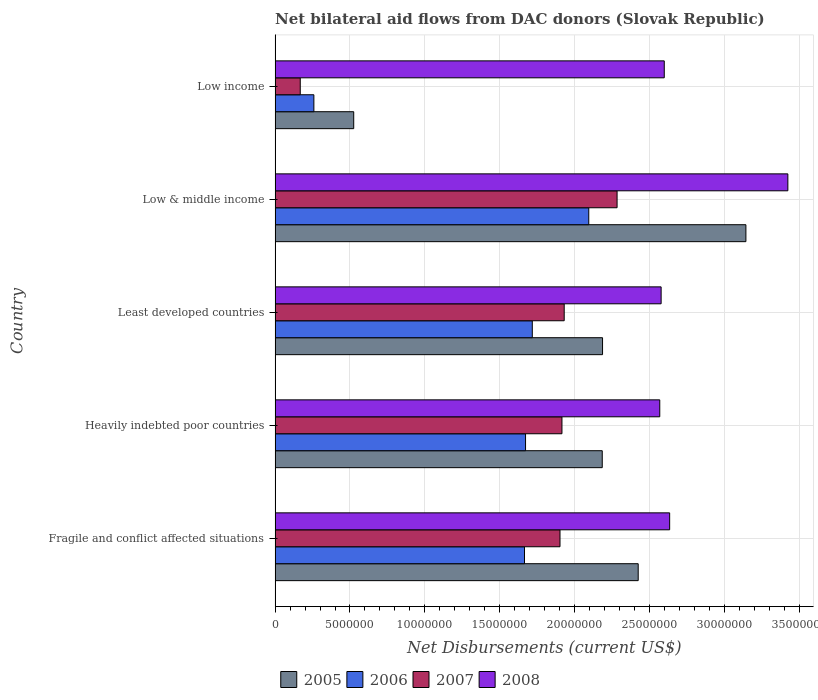How many different coloured bars are there?
Your answer should be compact. 4. How many groups of bars are there?
Give a very brief answer. 5. Are the number of bars per tick equal to the number of legend labels?
Give a very brief answer. Yes. Are the number of bars on each tick of the Y-axis equal?
Your response must be concise. Yes. How many bars are there on the 3rd tick from the top?
Keep it short and to the point. 4. In how many cases, is the number of bars for a given country not equal to the number of legend labels?
Provide a short and direct response. 0. What is the net bilateral aid flows in 2008 in Low & middle income?
Keep it short and to the point. 3.42e+07. Across all countries, what is the maximum net bilateral aid flows in 2005?
Keep it short and to the point. 3.14e+07. Across all countries, what is the minimum net bilateral aid flows in 2005?
Your answer should be compact. 5.25e+06. In which country was the net bilateral aid flows in 2007 maximum?
Your answer should be compact. Low & middle income. In which country was the net bilateral aid flows in 2006 minimum?
Your response must be concise. Low income. What is the total net bilateral aid flows in 2006 in the graph?
Your response must be concise. 7.41e+07. What is the difference between the net bilateral aid flows in 2006 in Fragile and conflict affected situations and that in Least developed countries?
Provide a succinct answer. -5.20e+05. What is the difference between the net bilateral aid flows in 2005 in Heavily indebted poor countries and the net bilateral aid flows in 2007 in Low income?
Ensure brevity in your answer.  2.02e+07. What is the average net bilateral aid flows in 2008 per country?
Your response must be concise. 2.76e+07. What is the difference between the net bilateral aid flows in 2007 and net bilateral aid flows in 2006 in Least developed countries?
Your answer should be compact. 2.13e+06. In how many countries, is the net bilateral aid flows in 2006 greater than 6000000 US$?
Offer a very short reply. 4. What is the ratio of the net bilateral aid flows in 2007 in Low & middle income to that in Low income?
Provide a succinct answer. 13.59. Is the difference between the net bilateral aid flows in 2007 in Heavily indebted poor countries and Low & middle income greater than the difference between the net bilateral aid flows in 2006 in Heavily indebted poor countries and Low & middle income?
Make the answer very short. Yes. What is the difference between the highest and the second highest net bilateral aid flows in 2006?
Your response must be concise. 3.77e+06. What is the difference between the highest and the lowest net bilateral aid flows in 2005?
Offer a very short reply. 2.62e+07. Is the sum of the net bilateral aid flows in 2006 in Low & middle income and Low income greater than the maximum net bilateral aid flows in 2007 across all countries?
Ensure brevity in your answer.  Yes. What does the 1st bar from the bottom in Low & middle income represents?
Your answer should be compact. 2005. Is it the case that in every country, the sum of the net bilateral aid flows in 2008 and net bilateral aid flows in 2005 is greater than the net bilateral aid flows in 2006?
Your response must be concise. Yes. Does the graph contain any zero values?
Provide a short and direct response. No. How are the legend labels stacked?
Make the answer very short. Horizontal. What is the title of the graph?
Your answer should be very brief. Net bilateral aid flows from DAC donors (Slovak Republic). Does "1971" appear as one of the legend labels in the graph?
Provide a succinct answer. No. What is the label or title of the X-axis?
Make the answer very short. Net Disbursements (current US$). What is the label or title of the Y-axis?
Provide a short and direct response. Country. What is the Net Disbursements (current US$) in 2005 in Fragile and conflict affected situations?
Your answer should be compact. 2.42e+07. What is the Net Disbursements (current US$) in 2006 in Fragile and conflict affected situations?
Offer a terse response. 1.66e+07. What is the Net Disbursements (current US$) of 2007 in Fragile and conflict affected situations?
Make the answer very short. 1.90e+07. What is the Net Disbursements (current US$) of 2008 in Fragile and conflict affected situations?
Your answer should be compact. 2.63e+07. What is the Net Disbursements (current US$) of 2005 in Heavily indebted poor countries?
Provide a succinct answer. 2.18e+07. What is the Net Disbursements (current US$) in 2006 in Heavily indebted poor countries?
Provide a short and direct response. 1.67e+07. What is the Net Disbursements (current US$) in 2007 in Heavily indebted poor countries?
Provide a short and direct response. 1.92e+07. What is the Net Disbursements (current US$) in 2008 in Heavily indebted poor countries?
Offer a very short reply. 2.57e+07. What is the Net Disbursements (current US$) of 2005 in Least developed countries?
Provide a short and direct response. 2.19e+07. What is the Net Disbursements (current US$) in 2006 in Least developed countries?
Ensure brevity in your answer.  1.72e+07. What is the Net Disbursements (current US$) in 2007 in Least developed countries?
Keep it short and to the point. 1.93e+07. What is the Net Disbursements (current US$) of 2008 in Least developed countries?
Make the answer very short. 2.58e+07. What is the Net Disbursements (current US$) in 2005 in Low & middle income?
Your answer should be compact. 3.14e+07. What is the Net Disbursements (current US$) in 2006 in Low & middle income?
Your answer should be compact. 2.09e+07. What is the Net Disbursements (current US$) in 2007 in Low & middle income?
Provide a short and direct response. 2.28e+07. What is the Net Disbursements (current US$) of 2008 in Low & middle income?
Your answer should be very brief. 3.42e+07. What is the Net Disbursements (current US$) of 2005 in Low income?
Ensure brevity in your answer.  5.25e+06. What is the Net Disbursements (current US$) of 2006 in Low income?
Provide a succinct answer. 2.59e+06. What is the Net Disbursements (current US$) in 2007 in Low income?
Your response must be concise. 1.68e+06. What is the Net Disbursements (current US$) of 2008 in Low income?
Offer a terse response. 2.60e+07. Across all countries, what is the maximum Net Disbursements (current US$) of 2005?
Your response must be concise. 3.14e+07. Across all countries, what is the maximum Net Disbursements (current US$) of 2006?
Your answer should be very brief. 2.09e+07. Across all countries, what is the maximum Net Disbursements (current US$) of 2007?
Ensure brevity in your answer.  2.28e+07. Across all countries, what is the maximum Net Disbursements (current US$) of 2008?
Your answer should be very brief. 3.42e+07. Across all countries, what is the minimum Net Disbursements (current US$) in 2005?
Keep it short and to the point. 5.25e+06. Across all countries, what is the minimum Net Disbursements (current US$) in 2006?
Provide a succinct answer. 2.59e+06. Across all countries, what is the minimum Net Disbursements (current US$) of 2007?
Make the answer very short. 1.68e+06. Across all countries, what is the minimum Net Disbursements (current US$) of 2008?
Your response must be concise. 2.57e+07. What is the total Net Disbursements (current US$) in 2005 in the graph?
Keep it short and to the point. 1.05e+08. What is the total Net Disbursements (current US$) of 2006 in the graph?
Make the answer very short. 7.41e+07. What is the total Net Disbursements (current US$) in 2007 in the graph?
Give a very brief answer. 8.20e+07. What is the total Net Disbursements (current US$) of 2008 in the graph?
Keep it short and to the point. 1.38e+08. What is the difference between the Net Disbursements (current US$) of 2005 in Fragile and conflict affected situations and that in Heavily indebted poor countries?
Make the answer very short. 2.40e+06. What is the difference between the Net Disbursements (current US$) in 2006 in Fragile and conflict affected situations and that in Heavily indebted poor countries?
Keep it short and to the point. -7.00e+04. What is the difference between the Net Disbursements (current US$) in 2005 in Fragile and conflict affected situations and that in Least developed countries?
Offer a very short reply. 2.38e+06. What is the difference between the Net Disbursements (current US$) of 2006 in Fragile and conflict affected situations and that in Least developed countries?
Offer a terse response. -5.20e+05. What is the difference between the Net Disbursements (current US$) of 2007 in Fragile and conflict affected situations and that in Least developed countries?
Provide a succinct answer. -2.80e+05. What is the difference between the Net Disbursements (current US$) in 2008 in Fragile and conflict affected situations and that in Least developed countries?
Your response must be concise. 5.70e+05. What is the difference between the Net Disbursements (current US$) of 2005 in Fragile and conflict affected situations and that in Low & middle income?
Provide a short and direct response. -7.19e+06. What is the difference between the Net Disbursements (current US$) of 2006 in Fragile and conflict affected situations and that in Low & middle income?
Make the answer very short. -4.29e+06. What is the difference between the Net Disbursements (current US$) in 2007 in Fragile and conflict affected situations and that in Low & middle income?
Provide a short and direct response. -3.81e+06. What is the difference between the Net Disbursements (current US$) of 2008 in Fragile and conflict affected situations and that in Low & middle income?
Your response must be concise. -7.89e+06. What is the difference between the Net Disbursements (current US$) of 2005 in Fragile and conflict affected situations and that in Low income?
Offer a very short reply. 1.90e+07. What is the difference between the Net Disbursements (current US$) of 2006 in Fragile and conflict affected situations and that in Low income?
Your answer should be compact. 1.41e+07. What is the difference between the Net Disbursements (current US$) in 2007 in Fragile and conflict affected situations and that in Low income?
Keep it short and to the point. 1.73e+07. What is the difference between the Net Disbursements (current US$) of 2008 in Fragile and conflict affected situations and that in Low income?
Your response must be concise. 3.60e+05. What is the difference between the Net Disbursements (current US$) of 2005 in Heavily indebted poor countries and that in Least developed countries?
Your answer should be compact. -2.00e+04. What is the difference between the Net Disbursements (current US$) in 2006 in Heavily indebted poor countries and that in Least developed countries?
Your answer should be very brief. -4.50e+05. What is the difference between the Net Disbursements (current US$) in 2007 in Heavily indebted poor countries and that in Least developed countries?
Keep it short and to the point. -1.50e+05. What is the difference between the Net Disbursements (current US$) of 2008 in Heavily indebted poor countries and that in Least developed countries?
Provide a succinct answer. -9.00e+04. What is the difference between the Net Disbursements (current US$) of 2005 in Heavily indebted poor countries and that in Low & middle income?
Give a very brief answer. -9.59e+06. What is the difference between the Net Disbursements (current US$) of 2006 in Heavily indebted poor countries and that in Low & middle income?
Provide a succinct answer. -4.22e+06. What is the difference between the Net Disbursements (current US$) in 2007 in Heavily indebted poor countries and that in Low & middle income?
Offer a terse response. -3.68e+06. What is the difference between the Net Disbursements (current US$) of 2008 in Heavily indebted poor countries and that in Low & middle income?
Offer a terse response. -8.55e+06. What is the difference between the Net Disbursements (current US$) in 2005 in Heavily indebted poor countries and that in Low income?
Provide a succinct answer. 1.66e+07. What is the difference between the Net Disbursements (current US$) of 2006 in Heavily indebted poor countries and that in Low income?
Your answer should be compact. 1.41e+07. What is the difference between the Net Disbursements (current US$) of 2007 in Heavily indebted poor countries and that in Low income?
Keep it short and to the point. 1.75e+07. What is the difference between the Net Disbursements (current US$) in 2008 in Heavily indebted poor countries and that in Low income?
Keep it short and to the point. -3.00e+05. What is the difference between the Net Disbursements (current US$) in 2005 in Least developed countries and that in Low & middle income?
Offer a terse response. -9.57e+06. What is the difference between the Net Disbursements (current US$) in 2006 in Least developed countries and that in Low & middle income?
Your response must be concise. -3.77e+06. What is the difference between the Net Disbursements (current US$) in 2007 in Least developed countries and that in Low & middle income?
Provide a succinct answer. -3.53e+06. What is the difference between the Net Disbursements (current US$) of 2008 in Least developed countries and that in Low & middle income?
Your answer should be compact. -8.46e+06. What is the difference between the Net Disbursements (current US$) of 2005 in Least developed countries and that in Low income?
Your response must be concise. 1.66e+07. What is the difference between the Net Disbursements (current US$) of 2006 in Least developed countries and that in Low income?
Your response must be concise. 1.46e+07. What is the difference between the Net Disbursements (current US$) in 2007 in Least developed countries and that in Low income?
Your response must be concise. 1.76e+07. What is the difference between the Net Disbursements (current US$) in 2005 in Low & middle income and that in Low income?
Provide a succinct answer. 2.62e+07. What is the difference between the Net Disbursements (current US$) of 2006 in Low & middle income and that in Low income?
Your answer should be compact. 1.84e+07. What is the difference between the Net Disbursements (current US$) of 2007 in Low & middle income and that in Low income?
Provide a short and direct response. 2.12e+07. What is the difference between the Net Disbursements (current US$) of 2008 in Low & middle income and that in Low income?
Offer a terse response. 8.25e+06. What is the difference between the Net Disbursements (current US$) of 2005 in Fragile and conflict affected situations and the Net Disbursements (current US$) of 2006 in Heavily indebted poor countries?
Your answer should be very brief. 7.52e+06. What is the difference between the Net Disbursements (current US$) of 2005 in Fragile and conflict affected situations and the Net Disbursements (current US$) of 2007 in Heavily indebted poor countries?
Ensure brevity in your answer.  5.09e+06. What is the difference between the Net Disbursements (current US$) of 2005 in Fragile and conflict affected situations and the Net Disbursements (current US$) of 2008 in Heavily indebted poor countries?
Ensure brevity in your answer.  -1.44e+06. What is the difference between the Net Disbursements (current US$) in 2006 in Fragile and conflict affected situations and the Net Disbursements (current US$) in 2007 in Heavily indebted poor countries?
Provide a short and direct response. -2.50e+06. What is the difference between the Net Disbursements (current US$) of 2006 in Fragile and conflict affected situations and the Net Disbursements (current US$) of 2008 in Heavily indebted poor countries?
Your answer should be very brief. -9.03e+06. What is the difference between the Net Disbursements (current US$) in 2007 in Fragile and conflict affected situations and the Net Disbursements (current US$) in 2008 in Heavily indebted poor countries?
Ensure brevity in your answer.  -6.66e+06. What is the difference between the Net Disbursements (current US$) of 2005 in Fragile and conflict affected situations and the Net Disbursements (current US$) of 2006 in Least developed countries?
Make the answer very short. 7.07e+06. What is the difference between the Net Disbursements (current US$) of 2005 in Fragile and conflict affected situations and the Net Disbursements (current US$) of 2007 in Least developed countries?
Your answer should be very brief. 4.94e+06. What is the difference between the Net Disbursements (current US$) in 2005 in Fragile and conflict affected situations and the Net Disbursements (current US$) in 2008 in Least developed countries?
Provide a short and direct response. -1.53e+06. What is the difference between the Net Disbursements (current US$) in 2006 in Fragile and conflict affected situations and the Net Disbursements (current US$) in 2007 in Least developed countries?
Your answer should be compact. -2.65e+06. What is the difference between the Net Disbursements (current US$) in 2006 in Fragile and conflict affected situations and the Net Disbursements (current US$) in 2008 in Least developed countries?
Give a very brief answer. -9.12e+06. What is the difference between the Net Disbursements (current US$) in 2007 in Fragile and conflict affected situations and the Net Disbursements (current US$) in 2008 in Least developed countries?
Keep it short and to the point. -6.75e+06. What is the difference between the Net Disbursements (current US$) of 2005 in Fragile and conflict affected situations and the Net Disbursements (current US$) of 2006 in Low & middle income?
Your answer should be very brief. 3.30e+06. What is the difference between the Net Disbursements (current US$) in 2005 in Fragile and conflict affected situations and the Net Disbursements (current US$) in 2007 in Low & middle income?
Provide a short and direct response. 1.41e+06. What is the difference between the Net Disbursements (current US$) in 2005 in Fragile and conflict affected situations and the Net Disbursements (current US$) in 2008 in Low & middle income?
Keep it short and to the point. -9.99e+06. What is the difference between the Net Disbursements (current US$) in 2006 in Fragile and conflict affected situations and the Net Disbursements (current US$) in 2007 in Low & middle income?
Keep it short and to the point. -6.18e+06. What is the difference between the Net Disbursements (current US$) of 2006 in Fragile and conflict affected situations and the Net Disbursements (current US$) of 2008 in Low & middle income?
Ensure brevity in your answer.  -1.76e+07. What is the difference between the Net Disbursements (current US$) of 2007 in Fragile and conflict affected situations and the Net Disbursements (current US$) of 2008 in Low & middle income?
Ensure brevity in your answer.  -1.52e+07. What is the difference between the Net Disbursements (current US$) of 2005 in Fragile and conflict affected situations and the Net Disbursements (current US$) of 2006 in Low income?
Give a very brief answer. 2.16e+07. What is the difference between the Net Disbursements (current US$) of 2005 in Fragile and conflict affected situations and the Net Disbursements (current US$) of 2007 in Low income?
Provide a succinct answer. 2.26e+07. What is the difference between the Net Disbursements (current US$) of 2005 in Fragile and conflict affected situations and the Net Disbursements (current US$) of 2008 in Low income?
Your response must be concise. -1.74e+06. What is the difference between the Net Disbursements (current US$) of 2006 in Fragile and conflict affected situations and the Net Disbursements (current US$) of 2007 in Low income?
Your response must be concise. 1.50e+07. What is the difference between the Net Disbursements (current US$) of 2006 in Fragile and conflict affected situations and the Net Disbursements (current US$) of 2008 in Low income?
Offer a terse response. -9.33e+06. What is the difference between the Net Disbursements (current US$) of 2007 in Fragile and conflict affected situations and the Net Disbursements (current US$) of 2008 in Low income?
Provide a succinct answer. -6.96e+06. What is the difference between the Net Disbursements (current US$) in 2005 in Heavily indebted poor countries and the Net Disbursements (current US$) in 2006 in Least developed countries?
Offer a terse response. 4.67e+06. What is the difference between the Net Disbursements (current US$) in 2005 in Heavily indebted poor countries and the Net Disbursements (current US$) in 2007 in Least developed countries?
Keep it short and to the point. 2.54e+06. What is the difference between the Net Disbursements (current US$) in 2005 in Heavily indebted poor countries and the Net Disbursements (current US$) in 2008 in Least developed countries?
Your answer should be very brief. -3.93e+06. What is the difference between the Net Disbursements (current US$) in 2006 in Heavily indebted poor countries and the Net Disbursements (current US$) in 2007 in Least developed countries?
Provide a succinct answer. -2.58e+06. What is the difference between the Net Disbursements (current US$) of 2006 in Heavily indebted poor countries and the Net Disbursements (current US$) of 2008 in Least developed countries?
Ensure brevity in your answer.  -9.05e+06. What is the difference between the Net Disbursements (current US$) of 2007 in Heavily indebted poor countries and the Net Disbursements (current US$) of 2008 in Least developed countries?
Provide a short and direct response. -6.62e+06. What is the difference between the Net Disbursements (current US$) in 2005 in Heavily indebted poor countries and the Net Disbursements (current US$) in 2007 in Low & middle income?
Your response must be concise. -9.90e+05. What is the difference between the Net Disbursements (current US$) of 2005 in Heavily indebted poor countries and the Net Disbursements (current US$) of 2008 in Low & middle income?
Offer a terse response. -1.24e+07. What is the difference between the Net Disbursements (current US$) in 2006 in Heavily indebted poor countries and the Net Disbursements (current US$) in 2007 in Low & middle income?
Provide a short and direct response. -6.11e+06. What is the difference between the Net Disbursements (current US$) of 2006 in Heavily indebted poor countries and the Net Disbursements (current US$) of 2008 in Low & middle income?
Offer a very short reply. -1.75e+07. What is the difference between the Net Disbursements (current US$) of 2007 in Heavily indebted poor countries and the Net Disbursements (current US$) of 2008 in Low & middle income?
Offer a terse response. -1.51e+07. What is the difference between the Net Disbursements (current US$) in 2005 in Heavily indebted poor countries and the Net Disbursements (current US$) in 2006 in Low income?
Your response must be concise. 1.92e+07. What is the difference between the Net Disbursements (current US$) in 2005 in Heavily indebted poor countries and the Net Disbursements (current US$) in 2007 in Low income?
Your response must be concise. 2.02e+07. What is the difference between the Net Disbursements (current US$) of 2005 in Heavily indebted poor countries and the Net Disbursements (current US$) of 2008 in Low income?
Your answer should be very brief. -4.14e+06. What is the difference between the Net Disbursements (current US$) in 2006 in Heavily indebted poor countries and the Net Disbursements (current US$) in 2007 in Low income?
Your response must be concise. 1.50e+07. What is the difference between the Net Disbursements (current US$) in 2006 in Heavily indebted poor countries and the Net Disbursements (current US$) in 2008 in Low income?
Your response must be concise. -9.26e+06. What is the difference between the Net Disbursements (current US$) in 2007 in Heavily indebted poor countries and the Net Disbursements (current US$) in 2008 in Low income?
Ensure brevity in your answer.  -6.83e+06. What is the difference between the Net Disbursements (current US$) in 2005 in Least developed countries and the Net Disbursements (current US$) in 2006 in Low & middle income?
Keep it short and to the point. 9.20e+05. What is the difference between the Net Disbursements (current US$) of 2005 in Least developed countries and the Net Disbursements (current US$) of 2007 in Low & middle income?
Offer a very short reply. -9.70e+05. What is the difference between the Net Disbursements (current US$) in 2005 in Least developed countries and the Net Disbursements (current US$) in 2008 in Low & middle income?
Provide a succinct answer. -1.24e+07. What is the difference between the Net Disbursements (current US$) in 2006 in Least developed countries and the Net Disbursements (current US$) in 2007 in Low & middle income?
Give a very brief answer. -5.66e+06. What is the difference between the Net Disbursements (current US$) of 2006 in Least developed countries and the Net Disbursements (current US$) of 2008 in Low & middle income?
Provide a short and direct response. -1.71e+07. What is the difference between the Net Disbursements (current US$) of 2007 in Least developed countries and the Net Disbursements (current US$) of 2008 in Low & middle income?
Ensure brevity in your answer.  -1.49e+07. What is the difference between the Net Disbursements (current US$) of 2005 in Least developed countries and the Net Disbursements (current US$) of 2006 in Low income?
Offer a very short reply. 1.93e+07. What is the difference between the Net Disbursements (current US$) in 2005 in Least developed countries and the Net Disbursements (current US$) in 2007 in Low income?
Your answer should be very brief. 2.02e+07. What is the difference between the Net Disbursements (current US$) in 2005 in Least developed countries and the Net Disbursements (current US$) in 2008 in Low income?
Provide a succinct answer. -4.12e+06. What is the difference between the Net Disbursements (current US$) of 2006 in Least developed countries and the Net Disbursements (current US$) of 2007 in Low income?
Provide a succinct answer. 1.55e+07. What is the difference between the Net Disbursements (current US$) of 2006 in Least developed countries and the Net Disbursements (current US$) of 2008 in Low income?
Provide a succinct answer. -8.81e+06. What is the difference between the Net Disbursements (current US$) of 2007 in Least developed countries and the Net Disbursements (current US$) of 2008 in Low income?
Give a very brief answer. -6.68e+06. What is the difference between the Net Disbursements (current US$) of 2005 in Low & middle income and the Net Disbursements (current US$) of 2006 in Low income?
Give a very brief answer. 2.88e+07. What is the difference between the Net Disbursements (current US$) of 2005 in Low & middle income and the Net Disbursements (current US$) of 2007 in Low income?
Your answer should be very brief. 2.98e+07. What is the difference between the Net Disbursements (current US$) in 2005 in Low & middle income and the Net Disbursements (current US$) in 2008 in Low income?
Offer a terse response. 5.45e+06. What is the difference between the Net Disbursements (current US$) in 2006 in Low & middle income and the Net Disbursements (current US$) in 2007 in Low income?
Provide a short and direct response. 1.93e+07. What is the difference between the Net Disbursements (current US$) of 2006 in Low & middle income and the Net Disbursements (current US$) of 2008 in Low income?
Provide a succinct answer. -5.04e+06. What is the difference between the Net Disbursements (current US$) in 2007 in Low & middle income and the Net Disbursements (current US$) in 2008 in Low income?
Keep it short and to the point. -3.15e+06. What is the average Net Disbursements (current US$) of 2005 per country?
Keep it short and to the point. 2.09e+07. What is the average Net Disbursements (current US$) of 2006 per country?
Keep it short and to the point. 1.48e+07. What is the average Net Disbursements (current US$) of 2007 per country?
Ensure brevity in your answer.  1.64e+07. What is the average Net Disbursements (current US$) in 2008 per country?
Give a very brief answer. 2.76e+07. What is the difference between the Net Disbursements (current US$) in 2005 and Net Disbursements (current US$) in 2006 in Fragile and conflict affected situations?
Keep it short and to the point. 7.59e+06. What is the difference between the Net Disbursements (current US$) in 2005 and Net Disbursements (current US$) in 2007 in Fragile and conflict affected situations?
Offer a terse response. 5.22e+06. What is the difference between the Net Disbursements (current US$) of 2005 and Net Disbursements (current US$) of 2008 in Fragile and conflict affected situations?
Provide a succinct answer. -2.10e+06. What is the difference between the Net Disbursements (current US$) of 2006 and Net Disbursements (current US$) of 2007 in Fragile and conflict affected situations?
Offer a terse response. -2.37e+06. What is the difference between the Net Disbursements (current US$) of 2006 and Net Disbursements (current US$) of 2008 in Fragile and conflict affected situations?
Your answer should be compact. -9.69e+06. What is the difference between the Net Disbursements (current US$) of 2007 and Net Disbursements (current US$) of 2008 in Fragile and conflict affected situations?
Keep it short and to the point. -7.32e+06. What is the difference between the Net Disbursements (current US$) in 2005 and Net Disbursements (current US$) in 2006 in Heavily indebted poor countries?
Offer a terse response. 5.12e+06. What is the difference between the Net Disbursements (current US$) of 2005 and Net Disbursements (current US$) of 2007 in Heavily indebted poor countries?
Provide a succinct answer. 2.69e+06. What is the difference between the Net Disbursements (current US$) of 2005 and Net Disbursements (current US$) of 2008 in Heavily indebted poor countries?
Give a very brief answer. -3.84e+06. What is the difference between the Net Disbursements (current US$) in 2006 and Net Disbursements (current US$) in 2007 in Heavily indebted poor countries?
Provide a succinct answer. -2.43e+06. What is the difference between the Net Disbursements (current US$) in 2006 and Net Disbursements (current US$) in 2008 in Heavily indebted poor countries?
Ensure brevity in your answer.  -8.96e+06. What is the difference between the Net Disbursements (current US$) in 2007 and Net Disbursements (current US$) in 2008 in Heavily indebted poor countries?
Offer a terse response. -6.53e+06. What is the difference between the Net Disbursements (current US$) of 2005 and Net Disbursements (current US$) of 2006 in Least developed countries?
Offer a terse response. 4.69e+06. What is the difference between the Net Disbursements (current US$) in 2005 and Net Disbursements (current US$) in 2007 in Least developed countries?
Your answer should be compact. 2.56e+06. What is the difference between the Net Disbursements (current US$) in 2005 and Net Disbursements (current US$) in 2008 in Least developed countries?
Ensure brevity in your answer.  -3.91e+06. What is the difference between the Net Disbursements (current US$) of 2006 and Net Disbursements (current US$) of 2007 in Least developed countries?
Provide a succinct answer. -2.13e+06. What is the difference between the Net Disbursements (current US$) of 2006 and Net Disbursements (current US$) of 2008 in Least developed countries?
Your answer should be very brief. -8.60e+06. What is the difference between the Net Disbursements (current US$) in 2007 and Net Disbursements (current US$) in 2008 in Least developed countries?
Make the answer very short. -6.47e+06. What is the difference between the Net Disbursements (current US$) in 2005 and Net Disbursements (current US$) in 2006 in Low & middle income?
Ensure brevity in your answer.  1.05e+07. What is the difference between the Net Disbursements (current US$) in 2005 and Net Disbursements (current US$) in 2007 in Low & middle income?
Offer a very short reply. 8.60e+06. What is the difference between the Net Disbursements (current US$) in 2005 and Net Disbursements (current US$) in 2008 in Low & middle income?
Your answer should be very brief. -2.80e+06. What is the difference between the Net Disbursements (current US$) of 2006 and Net Disbursements (current US$) of 2007 in Low & middle income?
Your answer should be very brief. -1.89e+06. What is the difference between the Net Disbursements (current US$) of 2006 and Net Disbursements (current US$) of 2008 in Low & middle income?
Make the answer very short. -1.33e+07. What is the difference between the Net Disbursements (current US$) in 2007 and Net Disbursements (current US$) in 2008 in Low & middle income?
Provide a short and direct response. -1.14e+07. What is the difference between the Net Disbursements (current US$) of 2005 and Net Disbursements (current US$) of 2006 in Low income?
Offer a terse response. 2.66e+06. What is the difference between the Net Disbursements (current US$) of 2005 and Net Disbursements (current US$) of 2007 in Low income?
Give a very brief answer. 3.57e+06. What is the difference between the Net Disbursements (current US$) of 2005 and Net Disbursements (current US$) of 2008 in Low income?
Ensure brevity in your answer.  -2.07e+07. What is the difference between the Net Disbursements (current US$) of 2006 and Net Disbursements (current US$) of 2007 in Low income?
Ensure brevity in your answer.  9.10e+05. What is the difference between the Net Disbursements (current US$) in 2006 and Net Disbursements (current US$) in 2008 in Low income?
Ensure brevity in your answer.  -2.34e+07. What is the difference between the Net Disbursements (current US$) of 2007 and Net Disbursements (current US$) of 2008 in Low income?
Make the answer very short. -2.43e+07. What is the ratio of the Net Disbursements (current US$) in 2005 in Fragile and conflict affected situations to that in Heavily indebted poor countries?
Offer a very short reply. 1.11. What is the ratio of the Net Disbursements (current US$) in 2007 in Fragile and conflict affected situations to that in Heavily indebted poor countries?
Your response must be concise. 0.99. What is the ratio of the Net Disbursements (current US$) in 2008 in Fragile and conflict affected situations to that in Heavily indebted poor countries?
Your answer should be very brief. 1.03. What is the ratio of the Net Disbursements (current US$) of 2005 in Fragile and conflict affected situations to that in Least developed countries?
Your answer should be very brief. 1.11. What is the ratio of the Net Disbursements (current US$) in 2006 in Fragile and conflict affected situations to that in Least developed countries?
Give a very brief answer. 0.97. What is the ratio of the Net Disbursements (current US$) of 2007 in Fragile and conflict affected situations to that in Least developed countries?
Offer a terse response. 0.99. What is the ratio of the Net Disbursements (current US$) in 2008 in Fragile and conflict affected situations to that in Least developed countries?
Offer a very short reply. 1.02. What is the ratio of the Net Disbursements (current US$) in 2005 in Fragile and conflict affected situations to that in Low & middle income?
Provide a short and direct response. 0.77. What is the ratio of the Net Disbursements (current US$) in 2006 in Fragile and conflict affected situations to that in Low & middle income?
Your answer should be very brief. 0.8. What is the ratio of the Net Disbursements (current US$) in 2007 in Fragile and conflict affected situations to that in Low & middle income?
Offer a terse response. 0.83. What is the ratio of the Net Disbursements (current US$) in 2008 in Fragile and conflict affected situations to that in Low & middle income?
Ensure brevity in your answer.  0.77. What is the ratio of the Net Disbursements (current US$) in 2005 in Fragile and conflict affected situations to that in Low income?
Your answer should be very brief. 4.62. What is the ratio of the Net Disbursements (current US$) in 2006 in Fragile and conflict affected situations to that in Low income?
Offer a very short reply. 6.43. What is the ratio of the Net Disbursements (current US$) in 2007 in Fragile and conflict affected situations to that in Low income?
Provide a succinct answer. 11.32. What is the ratio of the Net Disbursements (current US$) in 2008 in Fragile and conflict affected situations to that in Low income?
Provide a short and direct response. 1.01. What is the ratio of the Net Disbursements (current US$) of 2005 in Heavily indebted poor countries to that in Least developed countries?
Keep it short and to the point. 1. What is the ratio of the Net Disbursements (current US$) in 2006 in Heavily indebted poor countries to that in Least developed countries?
Offer a very short reply. 0.97. What is the ratio of the Net Disbursements (current US$) in 2008 in Heavily indebted poor countries to that in Least developed countries?
Provide a succinct answer. 1. What is the ratio of the Net Disbursements (current US$) in 2005 in Heavily indebted poor countries to that in Low & middle income?
Your answer should be very brief. 0.69. What is the ratio of the Net Disbursements (current US$) in 2006 in Heavily indebted poor countries to that in Low & middle income?
Make the answer very short. 0.8. What is the ratio of the Net Disbursements (current US$) in 2007 in Heavily indebted poor countries to that in Low & middle income?
Give a very brief answer. 0.84. What is the ratio of the Net Disbursements (current US$) of 2008 in Heavily indebted poor countries to that in Low & middle income?
Provide a short and direct response. 0.75. What is the ratio of the Net Disbursements (current US$) in 2005 in Heavily indebted poor countries to that in Low income?
Ensure brevity in your answer.  4.16. What is the ratio of the Net Disbursements (current US$) in 2006 in Heavily indebted poor countries to that in Low income?
Your answer should be compact. 6.46. What is the ratio of the Net Disbursements (current US$) of 2007 in Heavily indebted poor countries to that in Low income?
Your response must be concise. 11.4. What is the ratio of the Net Disbursements (current US$) in 2005 in Least developed countries to that in Low & middle income?
Provide a short and direct response. 0.7. What is the ratio of the Net Disbursements (current US$) of 2006 in Least developed countries to that in Low & middle income?
Ensure brevity in your answer.  0.82. What is the ratio of the Net Disbursements (current US$) of 2007 in Least developed countries to that in Low & middle income?
Make the answer very short. 0.85. What is the ratio of the Net Disbursements (current US$) in 2008 in Least developed countries to that in Low & middle income?
Your response must be concise. 0.75. What is the ratio of the Net Disbursements (current US$) of 2005 in Least developed countries to that in Low income?
Provide a short and direct response. 4.16. What is the ratio of the Net Disbursements (current US$) of 2006 in Least developed countries to that in Low income?
Ensure brevity in your answer.  6.63. What is the ratio of the Net Disbursements (current US$) in 2007 in Least developed countries to that in Low income?
Provide a succinct answer. 11.49. What is the ratio of the Net Disbursements (current US$) of 2008 in Least developed countries to that in Low income?
Your response must be concise. 0.99. What is the ratio of the Net Disbursements (current US$) in 2005 in Low & middle income to that in Low income?
Provide a succinct answer. 5.99. What is the ratio of the Net Disbursements (current US$) of 2006 in Low & middle income to that in Low income?
Offer a terse response. 8.08. What is the ratio of the Net Disbursements (current US$) in 2007 in Low & middle income to that in Low income?
Make the answer very short. 13.59. What is the ratio of the Net Disbursements (current US$) in 2008 in Low & middle income to that in Low income?
Provide a short and direct response. 1.32. What is the difference between the highest and the second highest Net Disbursements (current US$) of 2005?
Make the answer very short. 7.19e+06. What is the difference between the highest and the second highest Net Disbursements (current US$) in 2006?
Ensure brevity in your answer.  3.77e+06. What is the difference between the highest and the second highest Net Disbursements (current US$) of 2007?
Keep it short and to the point. 3.53e+06. What is the difference between the highest and the second highest Net Disbursements (current US$) of 2008?
Give a very brief answer. 7.89e+06. What is the difference between the highest and the lowest Net Disbursements (current US$) of 2005?
Make the answer very short. 2.62e+07. What is the difference between the highest and the lowest Net Disbursements (current US$) in 2006?
Your response must be concise. 1.84e+07. What is the difference between the highest and the lowest Net Disbursements (current US$) of 2007?
Ensure brevity in your answer.  2.12e+07. What is the difference between the highest and the lowest Net Disbursements (current US$) in 2008?
Keep it short and to the point. 8.55e+06. 